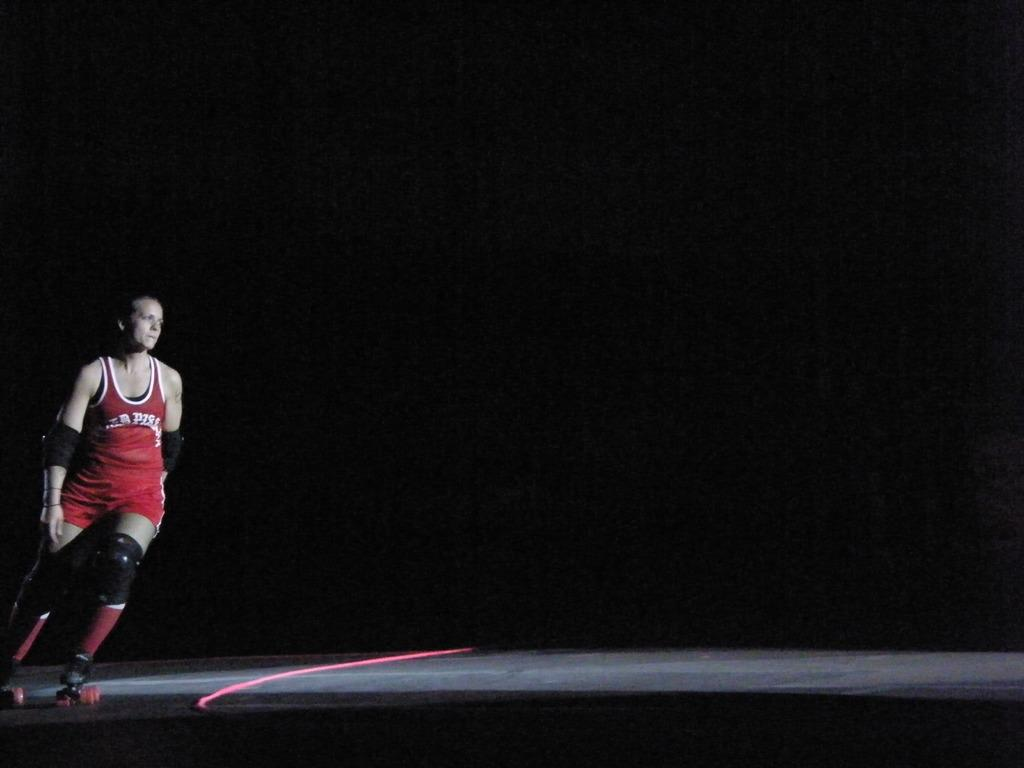What is the main subject of the image? The main subject of the image is a person on a skateboard. What protective gear is the person wearing? The person is wearing knee and elbow pads. What activity is the person engaged in? The person is skating. Can you describe any objects on the floor in the image? There is a red rope on the floor. How would you describe the lighting in the image? The background of the image is dark. What type of pie is being served at the end of the skateboard ramp in the image? There is no pie or skateboard ramp present in the image; it features a person on a skateboard with knee and elbow pads, a red rope on the floor, and a dark background. 